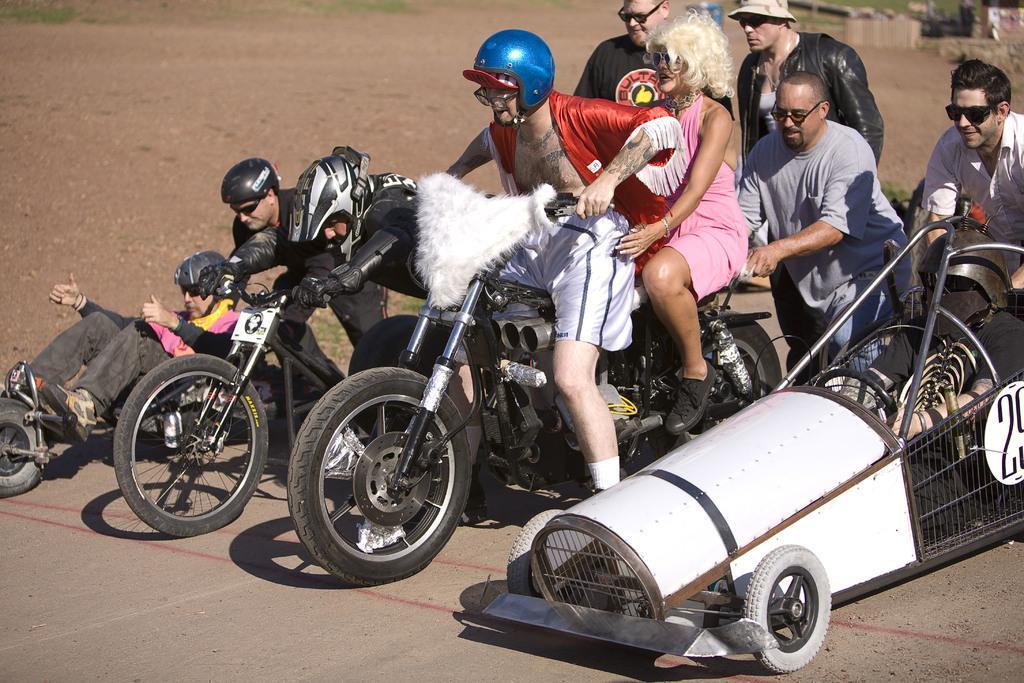Could you give a brief overview of what you see in this image? As we can see in the image there are few people sitting and standing. Two of them are sitting on motorcycle and one man is riding bicycle. 